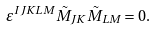<formula> <loc_0><loc_0><loc_500><loc_500>\varepsilon ^ { I J K L M } \tilde { M } _ { J K } \tilde { M } _ { L M } = 0 .</formula> 